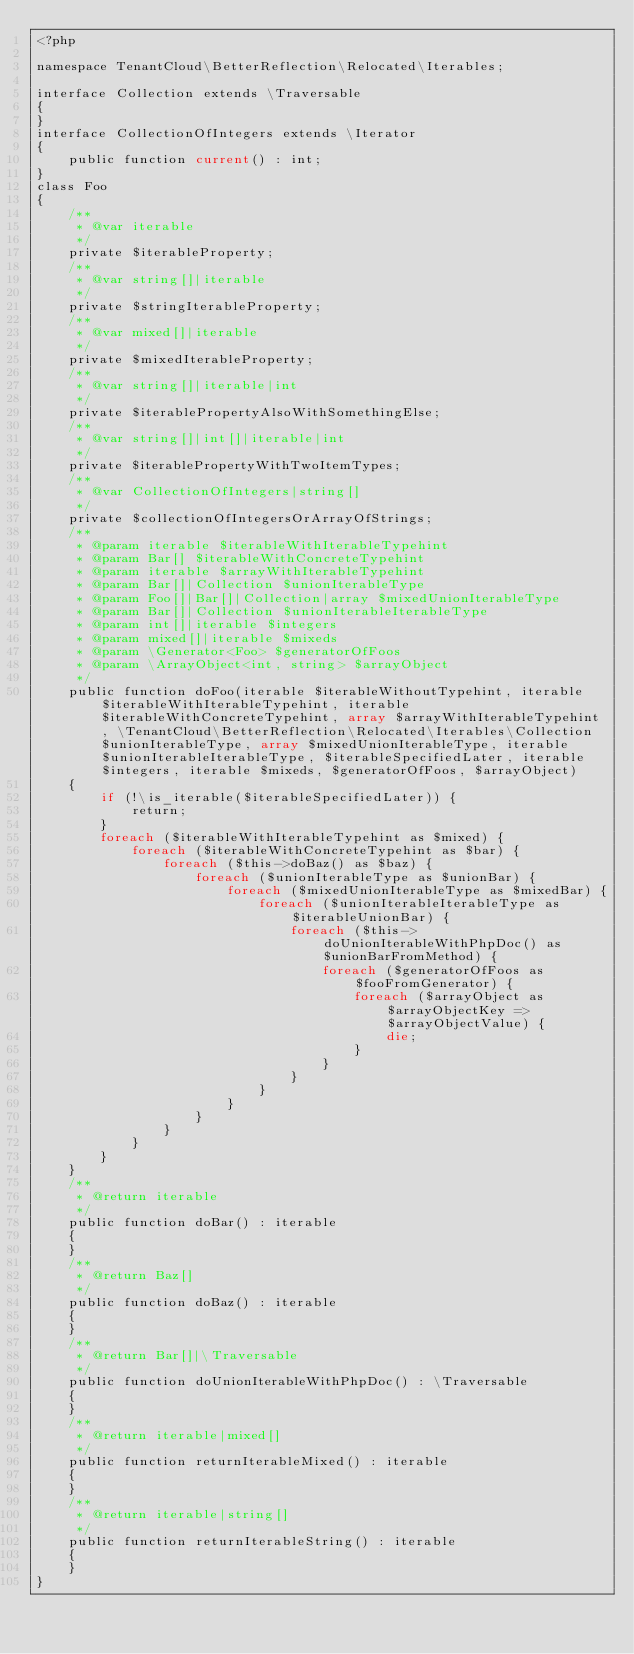<code> <loc_0><loc_0><loc_500><loc_500><_PHP_><?php

namespace TenantCloud\BetterReflection\Relocated\Iterables;

interface Collection extends \Traversable
{
}
interface CollectionOfIntegers extends \Iterator
{
    public function current() : int;
}
class Foo
{
    /**
     * @var iterable
     */
    private $iterableProperty;
    /**
     * @var string[]|iterable
     */
    private $stringIterableProperty;
    /**
     * @var mixed[]|iterable
     */
    private $mixedIterableProperty;
    /**
     * @var string[]|iterable|int
     */
    private $iterablePropertyAlsoWithSomethingElse;
    /**
     * @var string[]|int[]|iterable|int
     */
    private $iterablePropertyWithTwoItemTypes;
    /**
     * @var CollectionOfIntegers|string[]
     */
    private $collectionOfIntegersOrArrayOfStrings;
    /**
     * @param iterable $iterableWithIterableTypehint
     * @param Bar[] $iterableWithConcreteTypehint
     * @param iterable $arrayWithIterableTypehint
     * @param Bar[]|Collection $unionIterableType
     * @param Foo[]|Bar[]|Collection|array $mixedUnionIterableType
     * @param Bar[]|Collection $unionIterableIterableType
     * @param int[]|iterable $integers
     * @param mixed[]|iterable $mixeds
     * @param \Generator<Foo> $generatorOfFoos
     * @param \ArrayObject<int, string> $arrayObject
     */
    public function doFoo(iterable $iterableWithoutTypehint, iterable $iterableWithIterableTypehint, iterable $iterableWithConcreteTypehint, array $arrayWithIterableTypehint, \TenantCloud\BetterReflection\Relocated\Iterables\Collection $unionIterableType, array $mixedUnionIterableType, iterable $unionIterableIterableType, $iterableSpecifiedLater, iterable $integers, iterable $mixeds, $generatorOfFoos, $arrayObject)
    {
        if (!\is_iterable($iterableSpecifiedLater)) {
            return;
        }
        foreach ($iterableWithIterableTypehint as $mixed) {
            foreach ($iterableWithConcreteTypehint as $bar) {
                foreach ($this->doBaz() as $baz) {
                    foreach ($unionIterableType as $unionBar) {
                        foreach ($mixedUnionIterableType as $mixedBar) {
                            foreach ($unionIterableIterableType as $iterableUnionBar) {
                                foreach ($this->doUnionIterableWithPhpDoc() as $unionBarFromMethod) {
                                    foreach ($generatorOfFoos as $fooFromGenerator) {
                                        foreach ($arrayObject as $arrayObjectKey => $arrayObjectValue) {
                                            die;
                                        }
                                    }
                                }
                            }
                        }
                    }
                }
            }
        }
    }
    /**
     * @return iterable
     */
    public function doBar() : iterable
    {
    }
    /**
     * @return Baz[]
     */
    public function doBaz() : iterable
    {
    }
    /**
     * @return Bar[]|\Traversable
     */
    public function doUnionIterableWithPhpDoc() : \Traversable
    {
    }
    /**
     * @return iterable|mixed[]
     */
    public function returnIterableMixed() : iterable
    {
    }
    /**
     * @return iterable|string[]
     */
    public function returnIterableString() : iterable
    {
    }
}
</code> 